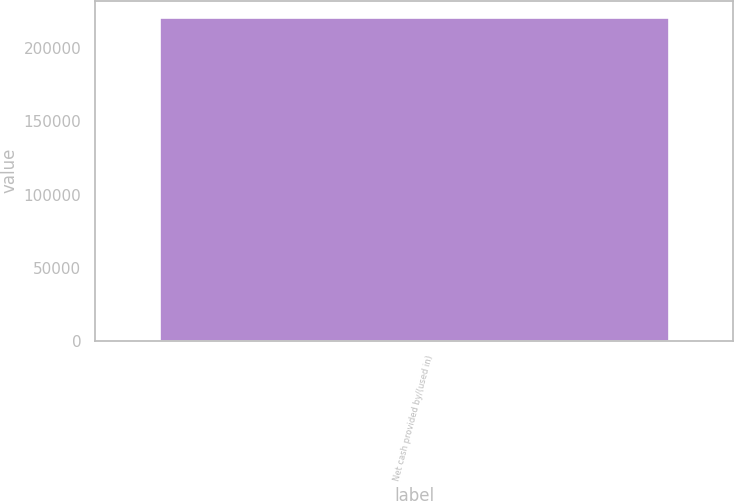Convert chart. <chart><loc_0><loc_0><loc_500><loc_500><bar_chart><fcel>Net cash provided by/(used in)<nl><fcel>221483<nl></chart> 